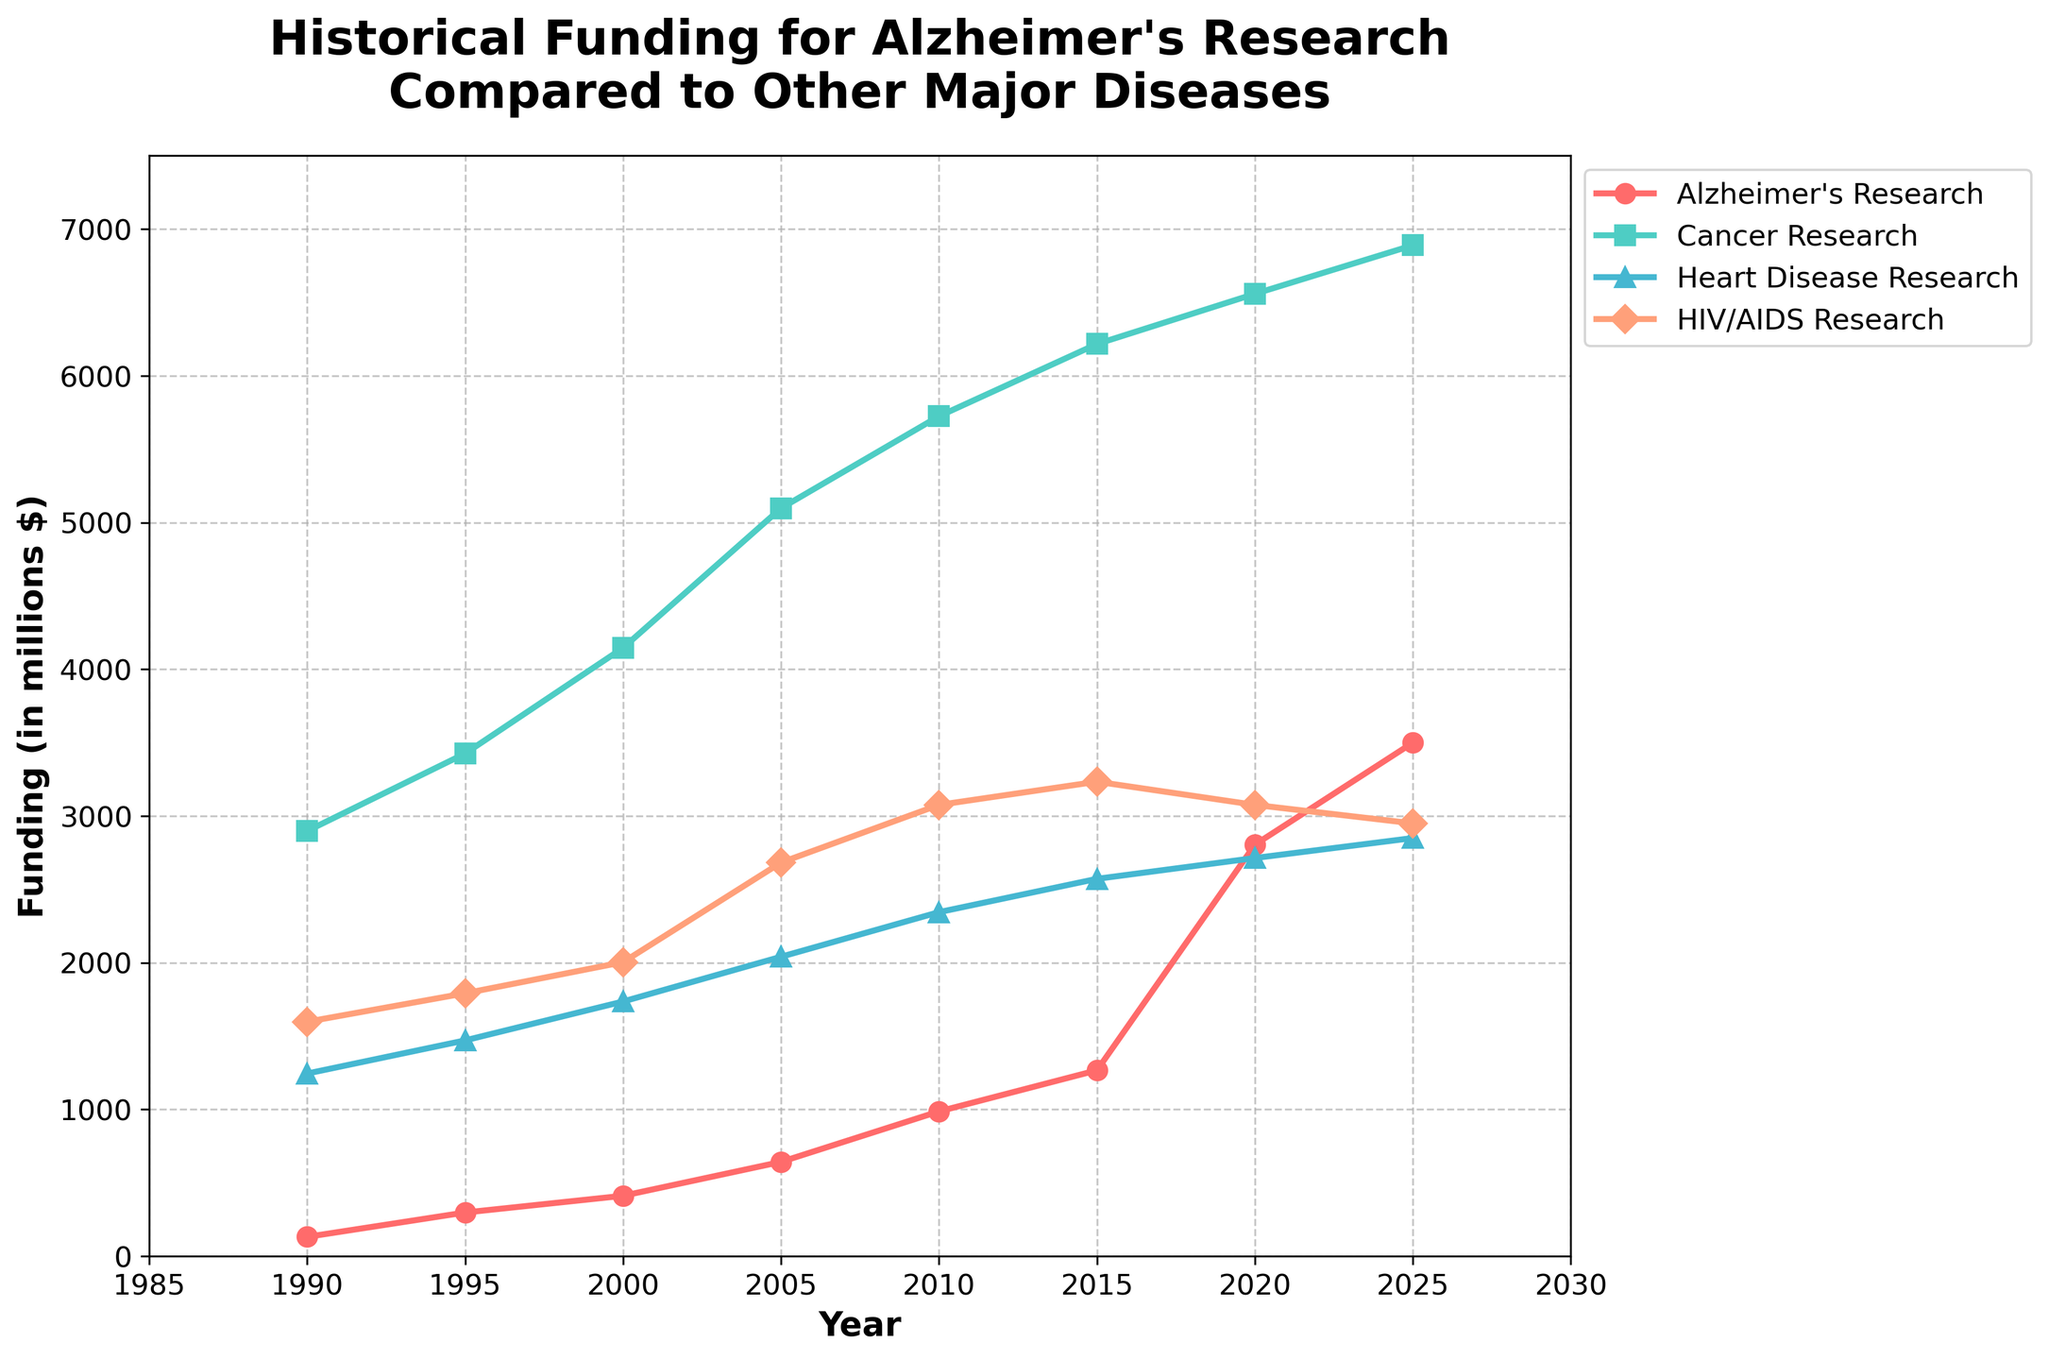What is the funding difference between Alzheimer's Research and Cancer Research in 2025? In 2025, funding for Alzheimer's Research is $3500 million and for Cancer Research is $6890 million. The difference is calculated as $6890 - $3500 = $3390 million.
Answer: $3390 million How much did funding for Heart Disease Research increase from 1990 to 2025? Funding in 1990 for Heart Disease Research was $1245 million and in 2025 it was $2850 million. The increase is calculated as $2850 - $1245 = $1605 million.
Answer: $1605 million Which disease had the highest funding in 2020, and what was that funding amount? In 2020, the funding for Alzheimer’s Research was $2805 million, Cancer Research was $6559 million, Heart Disease Research was $2714 million, and HIV/AIDS Research was $3076 million. The highest funding was for Cancer Research at $6559 million.
Answer: Cancer Research, $6559 million What is the average funding for HIV/AIDS Research over the entire period (1990 to 2025)? Sum the funding amounts for HIV/AIDS Research from 1990 to 2025 and divide by the number of years (8). Sum: $1598 + $1792 + $2004 + $2683 + $3076 + $3234 + $3076 + $2950 = $20413 million. Dividing by 8, the average funding is approximately $2551.6 million.
Answer: $2551.6 million Which disease showed the largest percentage increase in funding from 1990 to 2025? Calculate the percentage increase for each disease. For Alzheimer's Research: ((3500 - 132) / 132) * 100 ≈ 2552.27%. For Cancer Research: ((6890 - 2898) / 2898) * 100 ≈ 137.75%. For Heart Disease Research: ((2850 - 1245) / 1245) * 100 ≈ 128.92%. For HIV/AIDS Research: ((2950 - 1598) / 1598) * 100 ≈ 84.80%. The largest percentage increase is for Alzheimer’s Research.
Answer: Alzheimer’s Research In which year did Alzheimer's Research funding surpass $1000 million, and by how much? Alzheimer's Research funding surpassed $1000 million in 2015 when it reached $1267 million. The amount by which it surpassed is calculated as $1267 - $1000 = $267 million.
Answer: 2015, $267 million What is the overall trend for Cancer Research funding over the given years? Observing the data, Cancer Research funding consistently increases from $2898 million in 1990 to $6890 million in 2025. This indicates a consistent upward trend.
Answer: Upward trend Which disease had the least funding increase from 2015 to 2020, and what was the increase? Calculate the increase for each disease between 2015 and 2020. Alzheimer's Research: $2805 - $1267 = $1538 million. Cancer Research: $6559 - $6217 = $342 million. Heart Disease Research: $2714 - $2572 = $142 million. HIV/AIDS Research: $3076 - $3234 = $-158 million. Heart Disease Research had the least increase of $142 million among those with positive changes.
Answer: Heart Disease Research, $142 million 